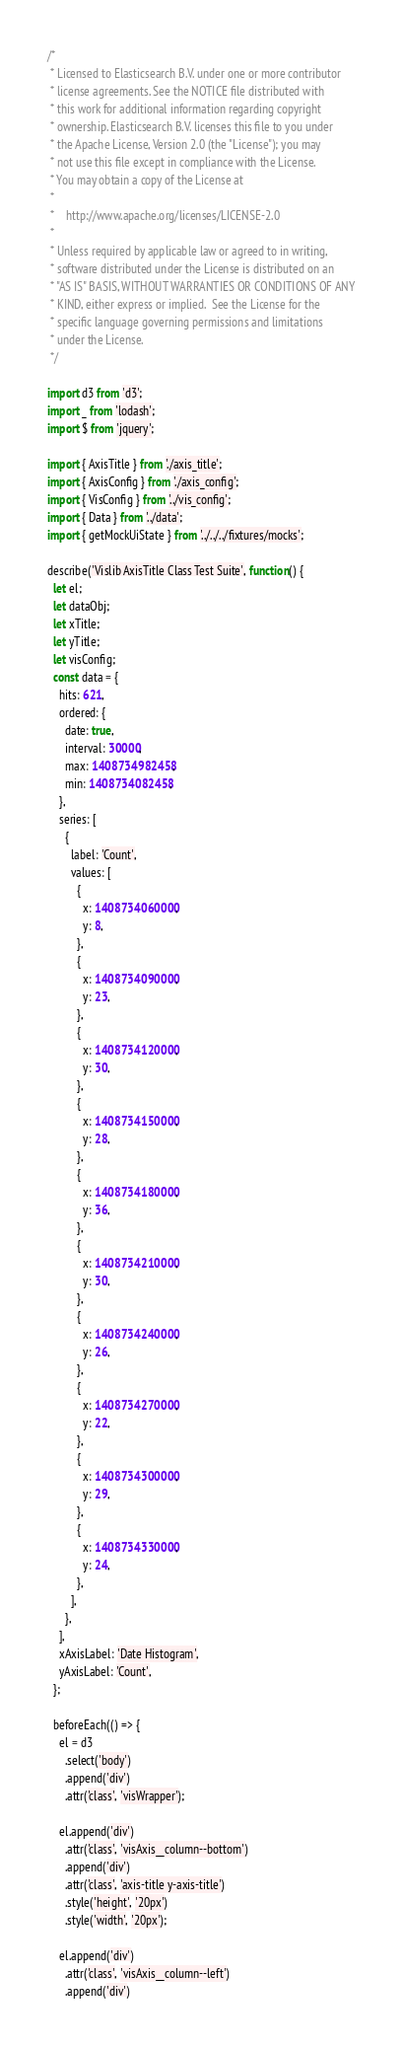Convert code to text. <code><loc_0><loc_0><loc_500><loc_500><_JavaScript_>/*
 * Licensed to Elasticsearch B.V. under one or more contributor
 * license agreements. See the NOTICE file distributed with
 * this work for additional information regarding copyright
 * ownership. Elasticsearch B.V. licenses this file to you under
 * the Apache License, Version 2.0 (the "License"); you may
 * not use this file except in compliance with the License.
 * You may obtain a copy of the License at
 *
 *    http://www.apache.org/licenses/LICENSE-2.0
 *
 * Unless required by applicable law or agreed to in writing,
 * software distributed under the License is distributed on an
 * "AS IS" BASIS, WITHOUT WARRANTIES OR CONDITIONS OF ANY
 * KIND, either express or implied.  See the License for the
 * specific language governing permissions and limitations
 * under the License.
 */

import d3 from 'd3';
import _ from 'lodash';
import $ from 'jquery';

import { AxisTitle } from './axis_title';
import { AxisConfig } from './axis_config';
import { VisConfig } from '../vis_config';
import { Data } from '../data';
import { getMockUiState } from '../../../fixtures/mocks';

describe('Vislib AxisTitle Class Test Suite', function() {
  let el;
  let dataObj;
  let xTitle;
  let yTitle;
  let visConfig;
  const data = {
    hits: 621,
    ordered: {
      date: true,
      interval: 30000,
      max: 1408734982458,
      min: 1408734082458,
    },
    series: [
      {
        label: 'Count',
        values: [
          {
            x: 1408734060000,
            y: 8,
          },
          {
            x: 1408734090000,
            y: 23,
          },
          {
            x: 1408734120000,
            y: 30,
          },
          {
            x: 1408734150000,
            y: 28,
          },
          {
            x: 1408734180000,
            y: 36,
          },
          {
            x: 1408734210000,
            y: 30,
          },
          {
            x: 1408734240000,
            y: 26,
          },
          {
            x: 1408734270000,
            y: 22,
          },
          {
            x: 1408734300000,
            y: 29,
          },
          {
            x: 1408734330000,
            y: 24,
          },
        ],
      },
    ],
    xAxisLabel: 'Date Histogram',
    yAxisLabel: 'Count',
  };

  beforeEach(() => {
    el = d3
      .select('body')
      .append('div')
      .attr('class', 'visWrapper');

    el.append('div')
      .attr('class', 'visAxis__column--bottom')
      .append('div')
      .attr('class', 'axis-title y-axis-title')
      .style('height', '20px')
      .style('width', '20px');

    el.append('div')
      .attr('class', 'visAxis__column--left')
      .append('div')</code> 